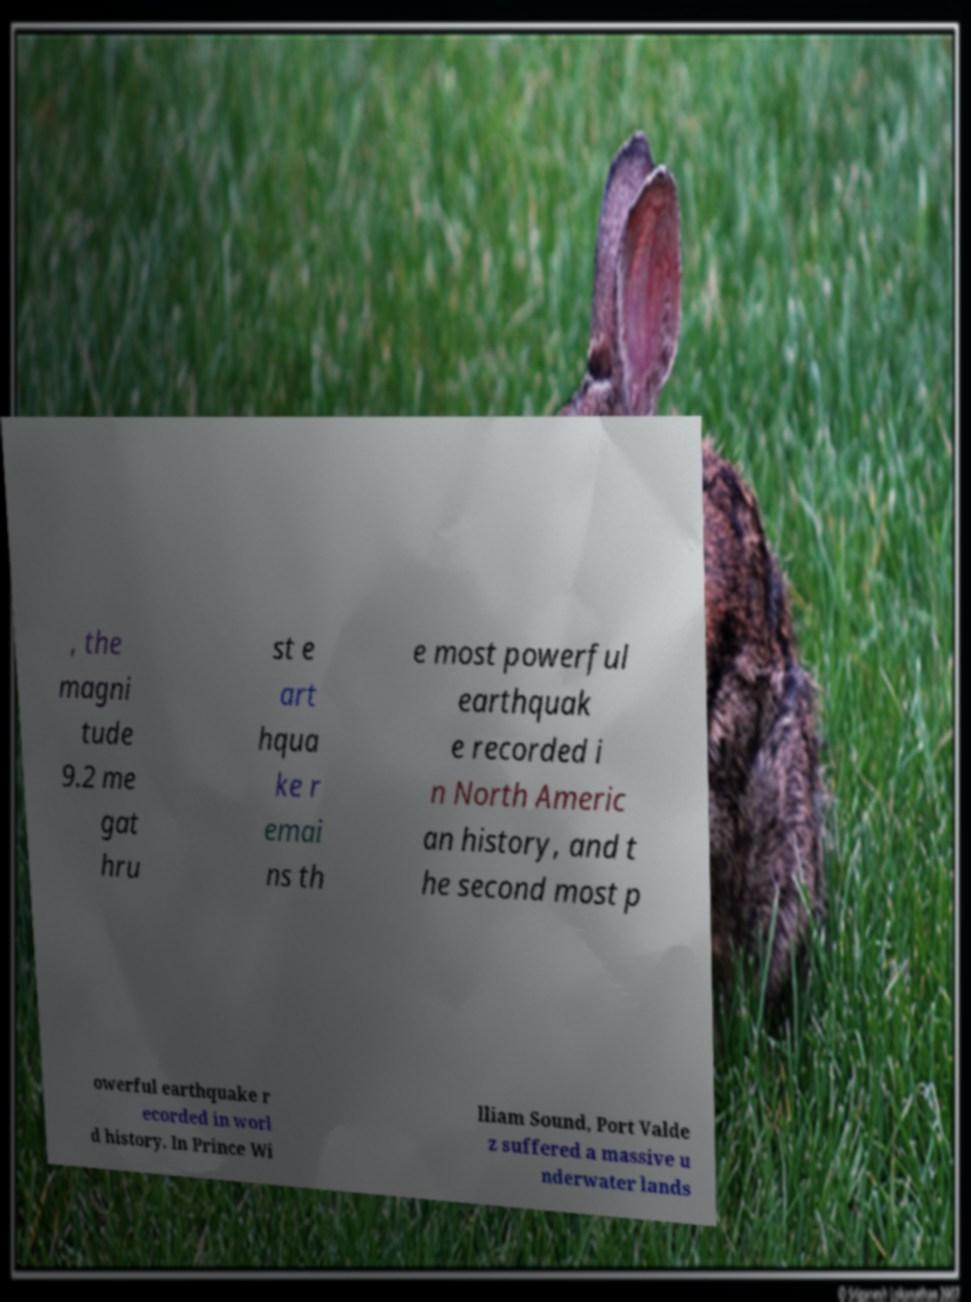There's text embedded in this image that I need extracted. Can you transcribe it verbatim? , the magni tude 9.2 me gat hru st e art hqua ke r emai ns th e most powerful earthquak e recorded i n North Americ an history, and t he second most p owerful earthquake r ecorded in worl d history. In Prince Wi lliam Sound, Port Valde z suffered a massive u nderwater lands 